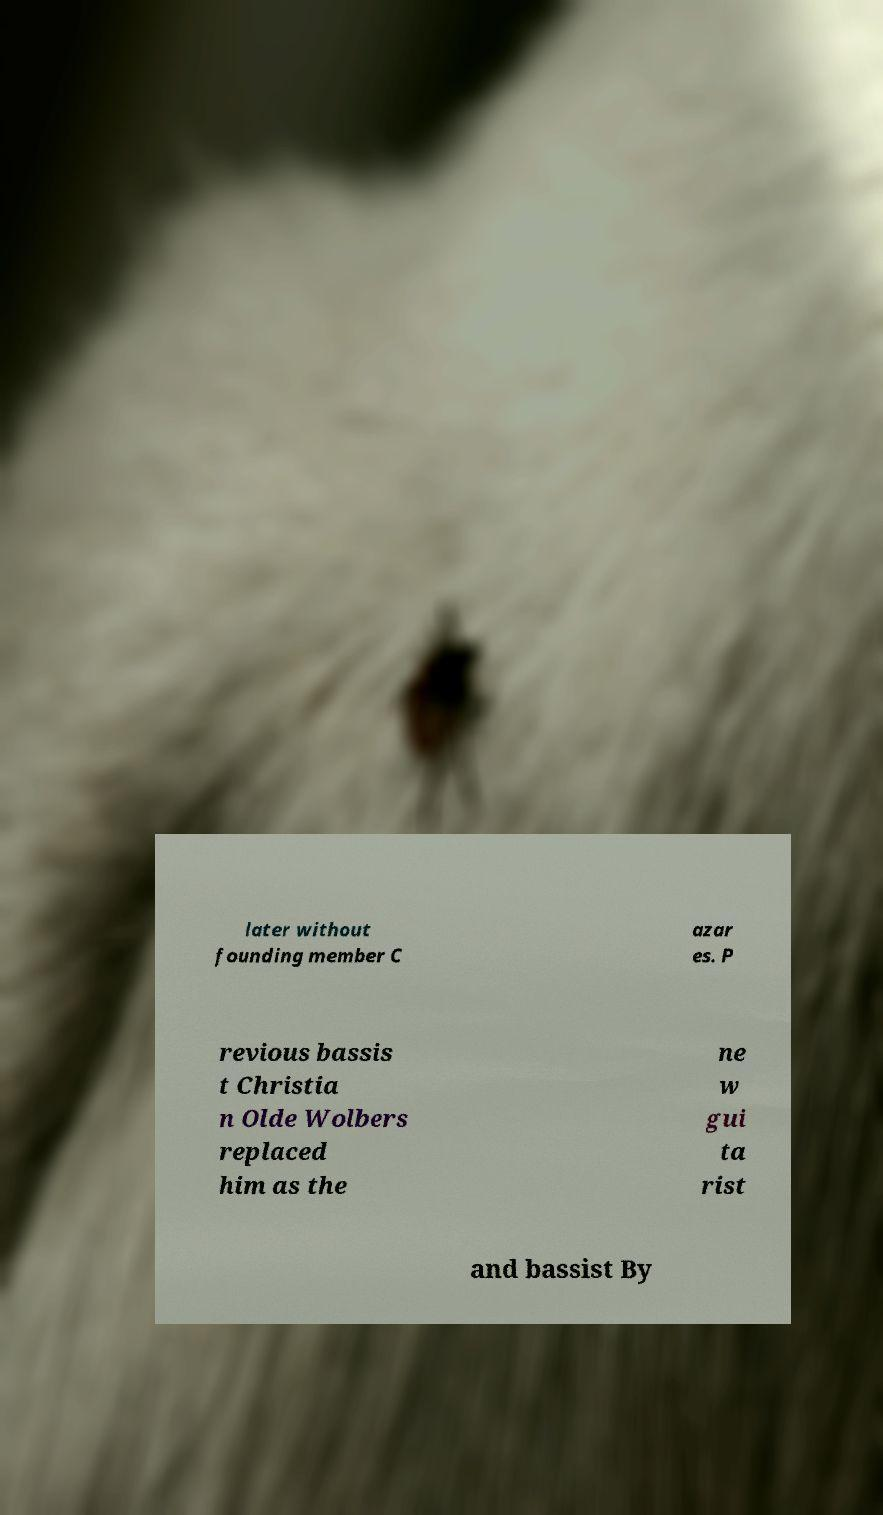Can you accurately transcribe the text from the provided image for me? later without founding member C azar es. P revious bassis t Christia n Olde Wolbers replaced him as the ne w gui ta rist and bassist By 